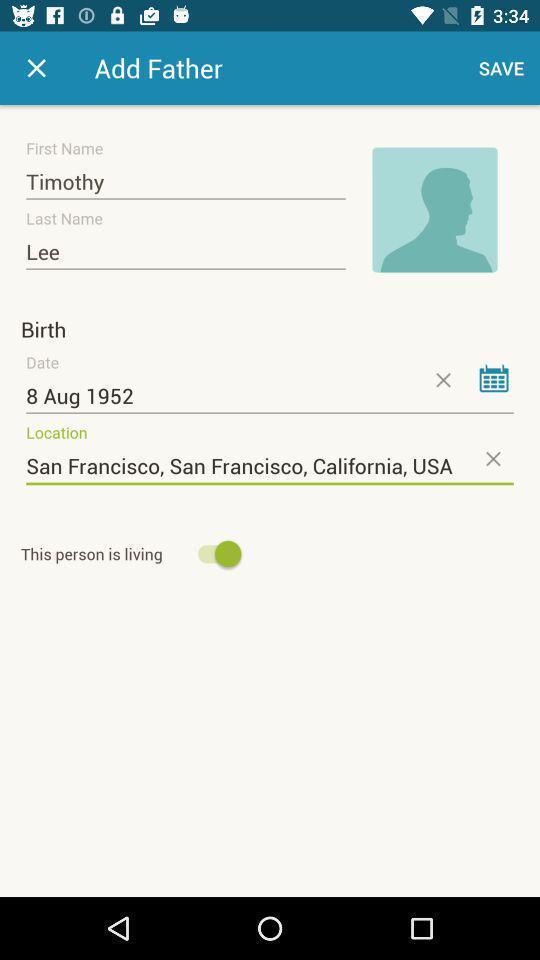Give me a summary of this screen capture. Screen showing add father details. 